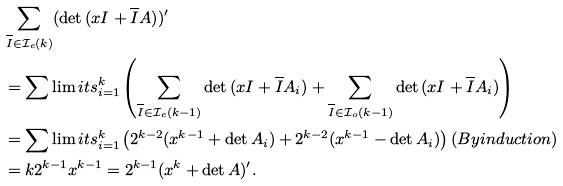<formula> <loc_0><loc_0><loc_500><loc_500>& \sum _ { \overline { I } \in \mathcal { I } _ { e } ( k ) } ( \det { ( x I + \overline { I } A ) } ) ^ { \prime } \\ & = \sum \lim i t s _ { i = 1 } ^ { k } \left ( \sum _ { \overline { I } \in \mathcal { I } _ { e } ( k - 1 ) } \det { ( x I + \overline { I } A _ { i } ) } + \sum _ { \overline { I } \in \mathcal { I } _ { o } ( k - 1 ) } \det { ( x I + \overline { I } A _ { i } ) } \right ) \\ & = \sum \lim i t s _ { i = 1 } ^ { k } \left ( 2 ^ { k - 2 } ( x ^ { k - 1 } + \det { A _ { i } } ) + 2 ^ { k - 2 } ( x ^ { k - 1 } - \det { A _ { i } } ) \right ) ( B y i n d u c t i o n ) \\ & = k 2 ^ { k - 1 } x ^ { k - 1 } = 2 ^ { k - 1 } ( x ^ { k } + \det { A } ) ^ { \prime } .</formula> 